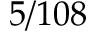<formula> <loc_0><loc_0><loc_500><loc_500>5 / 1 0 8</formula> 